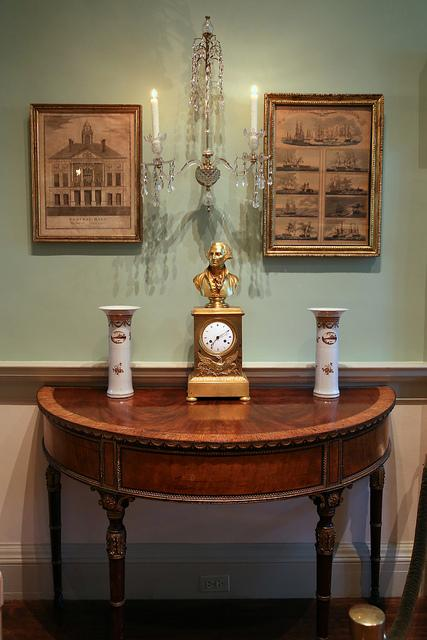How many items on the table are to the left of the clock?

Choices:
A) five
B) one
C) three
D) four one 